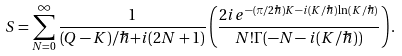Convert formula to latex. <formula><loc_0><loc_0><loc_500><loc_500>S = \sum _ { N = 0 } ^ { \infty } \frac { 1 } { ( Q - K ) / \hbar { + } i ( 2 N + 1 ) } \left ( \frac { 2 i e ^ { - ( \pi / 2 \hbar { ) } K - i ( K / \hbar { ) } \ln ( K / \hbar { ) } } } { N ! \Gamma ( - N - i ( K / \hbar { ) } ) } \right ) .</formula> 